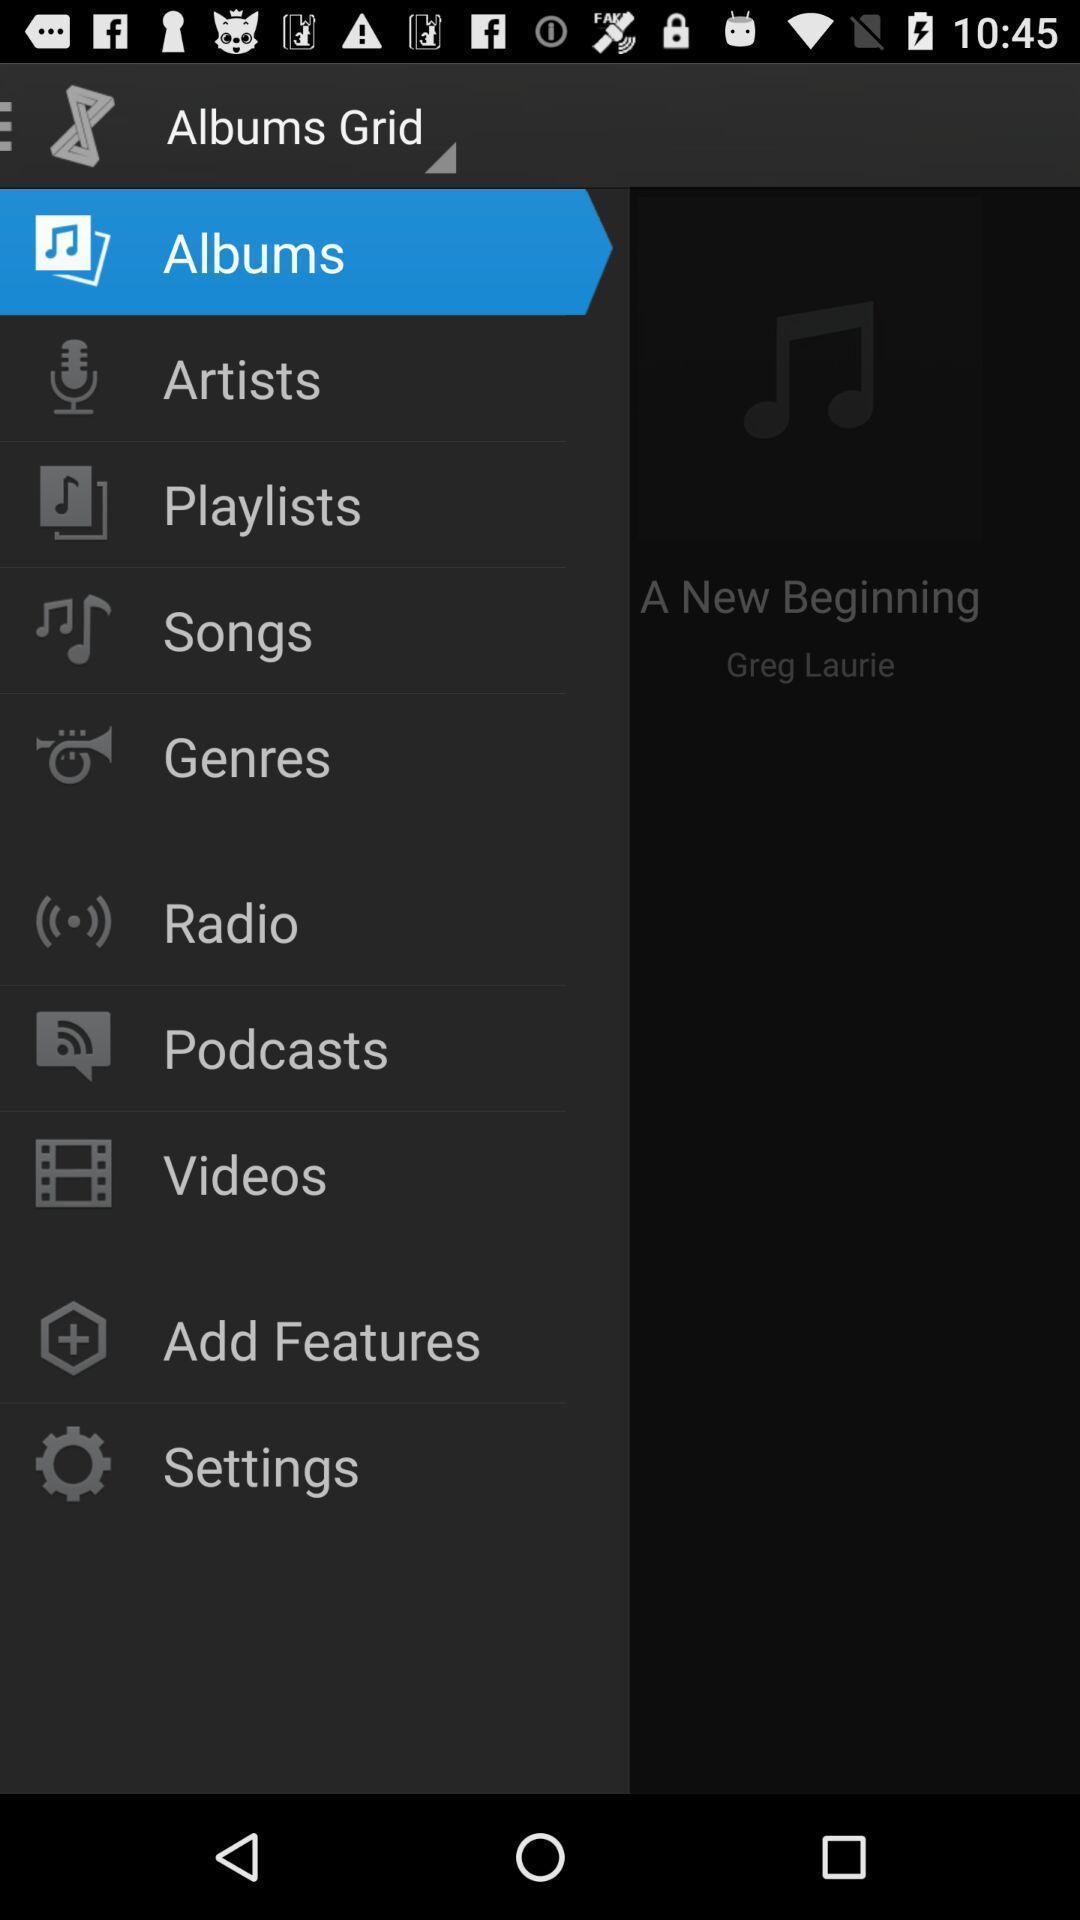Explain the elements present in this screenshot. Page displaying the settings page of the music player application. 